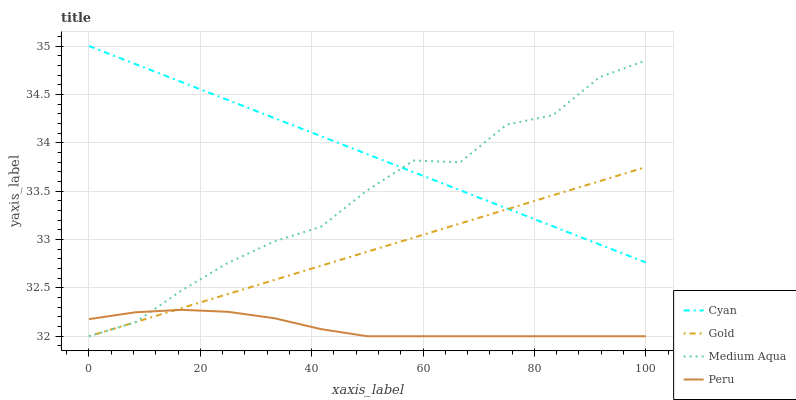Does Peru have the minimum area under the curve?
Answer yes or no. Yes. Does Cyan have the maximum area under the curve?
Answer yes or no. Yes. Does Medium Aqua have the minimum area under the curve?
Answer yes or no. No. Does Medium Aqua have the maximum area under the curve?
Answer yes or no. No. Is Cyan the smoothest?
Answer yes or no. Yes. Is Medium Aqua the roughest?
Answer yes or no. Yes. Is Peru the smoothest?
Answer yes or no. No. Is Peru the roughest?
Answer yes or no. No. Does Medium Aqua have the lowest value?
Answer yes or no. Yes. Does Cyan have the highest value?
Answer yes or no. Yes. Does Medium Aqua have the highest value?
Answer yes or no. No. Is Peru less than Cyan?
Answer yes or no. Yes. Is Cyan greater than Peru?
Answer yes or no. Yes. Does Peru intersect Gold?
Answer yes or no. Yes. Is Peru less than Gold?
Answer yes or no. No. Is Peru greater than Gold?
Answer yes or no. No. Does Peru intersect Cyan?
Answer yes or no. No. 